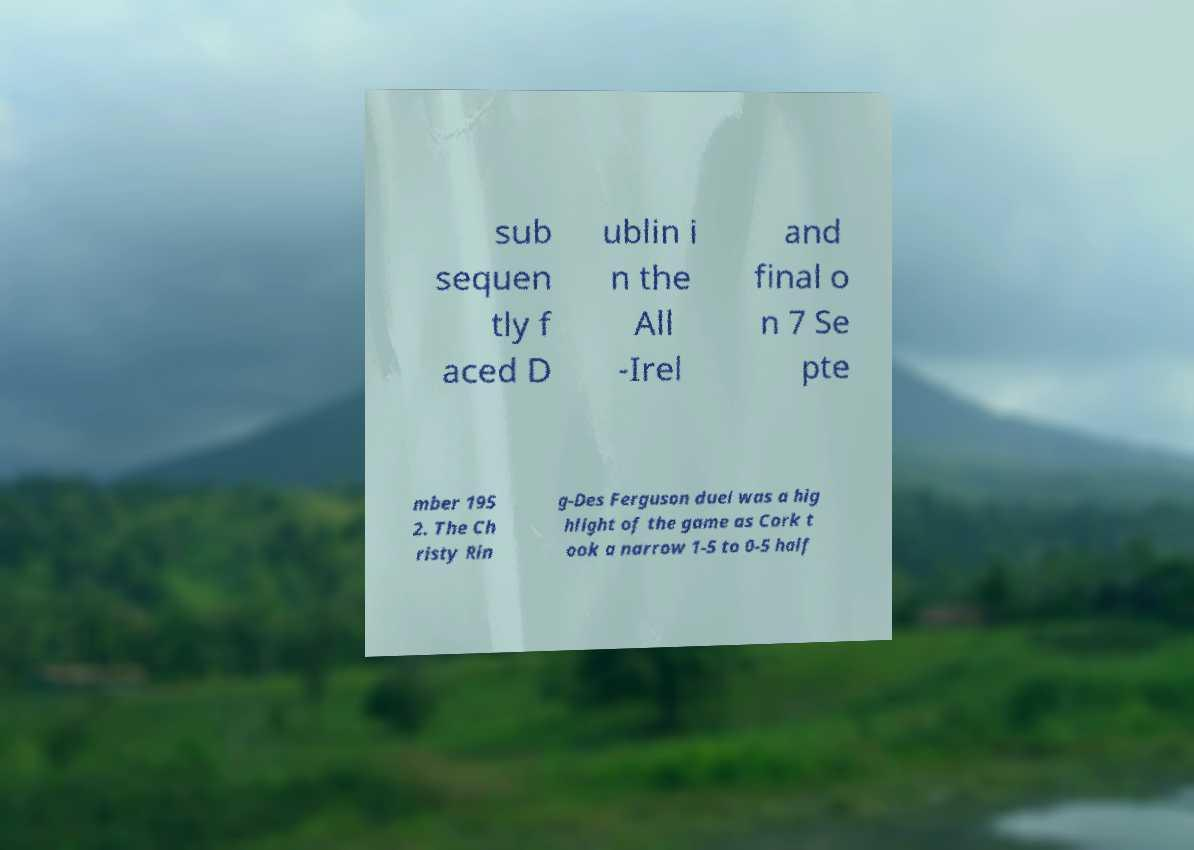What messages or text are displayed in this image? I need them in a readable, typed format. sub sequen tly f aced D ublin i n the All -Irel and final o n 7 Se pte mber 195 2. The Ch risty Rin g-Des Ferguson duel was a hig hlight of the game as Cork t ook a narrow 1-5 to 0-5 half 